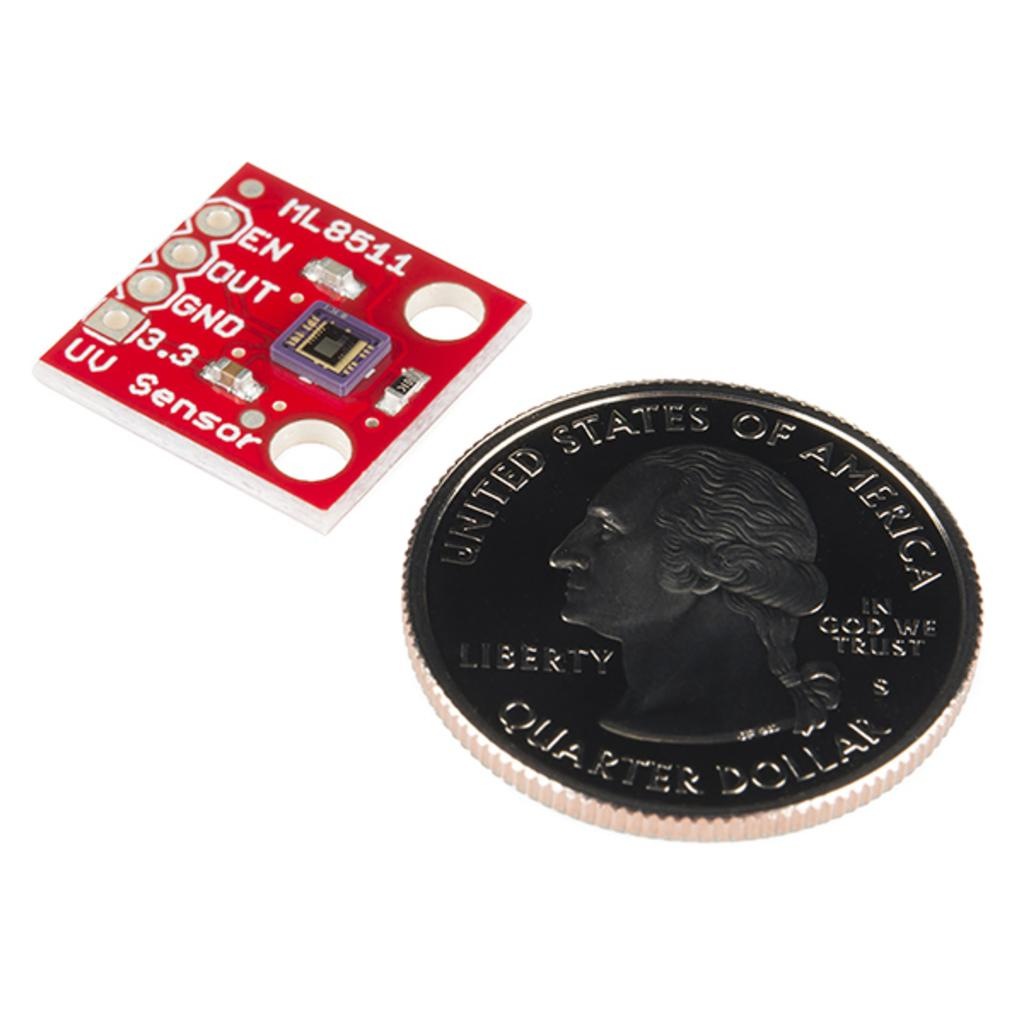Provide a one-sentence caption for the provided image. A coin that has the United States of America written on it. 